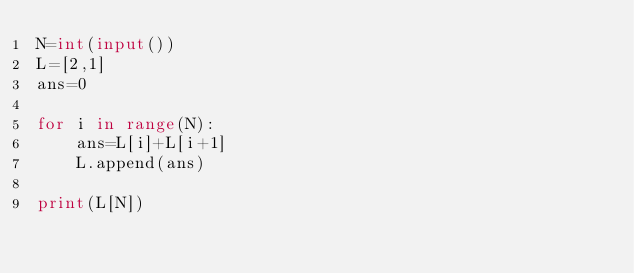Convert code to text. <code><loc_0><loc_0><loc_500><loc_500><_Python_>N=int(input())
L=[2,1]
ans=0

for i in range(N):
    ans=L[i]+L[i+1]
    L.append(ans)
    
print(L[N])</code> 